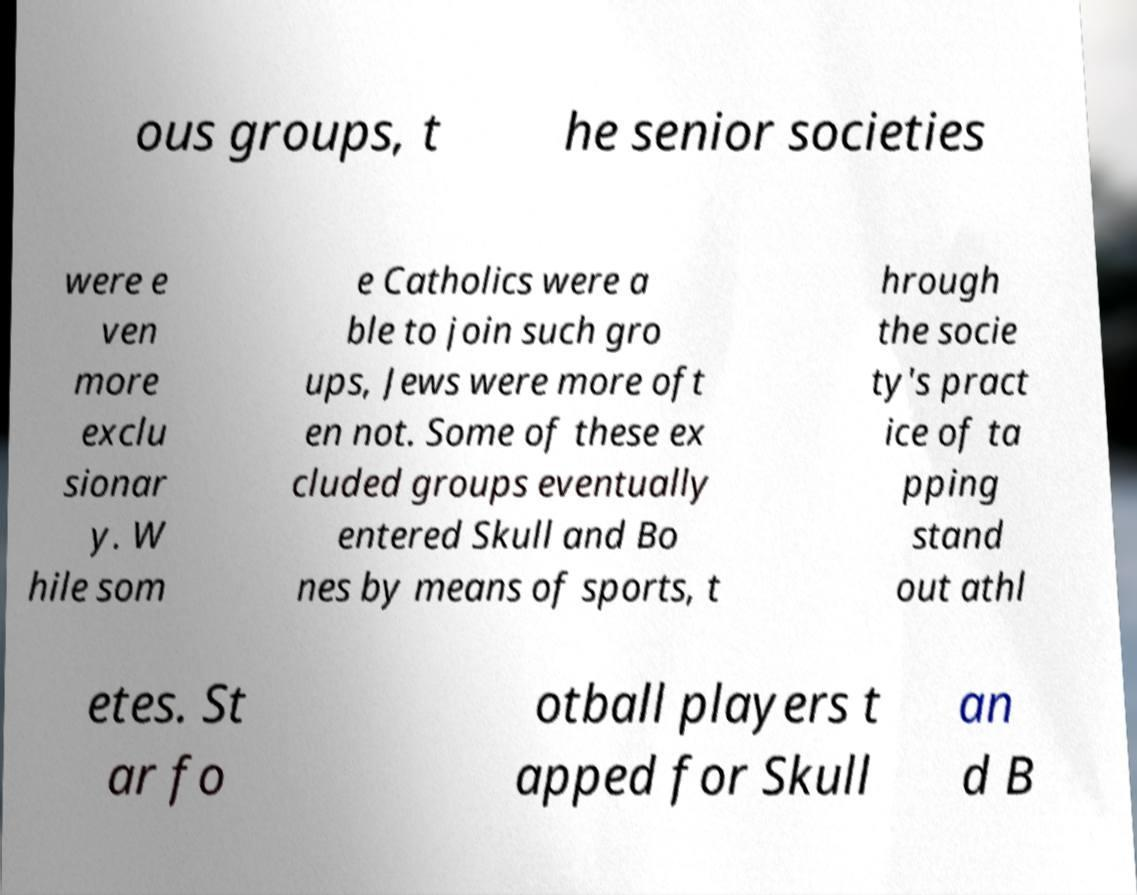Please identify and transcribe the text found in this image. ous groups, t he senior societies were e ven more exclu sionar y. W hile som e Catholics were a ble to join such gro ups, Jews were more oft en not. Some of these ex cluded groups eventually entered Skull and Bo nes by means of sports, t hrough the socie ty's pract ice of ta pping stand out athl etes. St ar fo otball players t apped for Skull an d B 